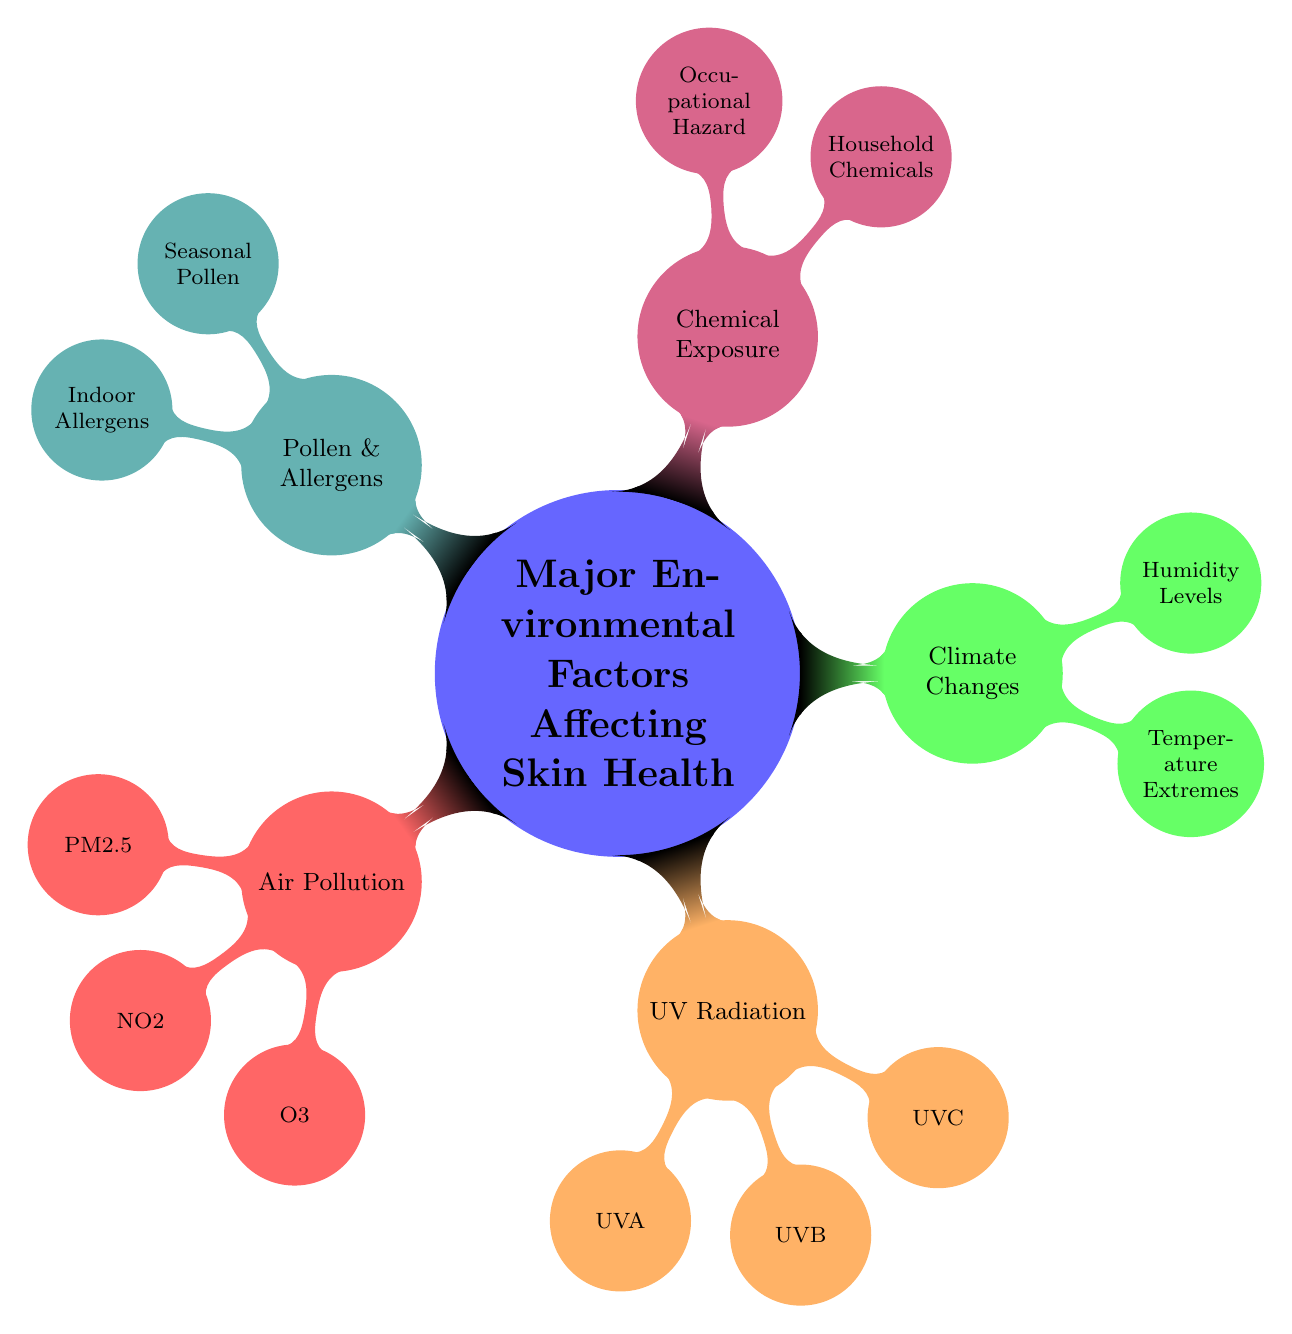What are the three main categories of environmental factors affecting skin health? The diagram shows five main categories, but the question specifically asks for three main ones. By identifying the major nodes directly connected to the central concept, we see those are Air Pollution, UV Radiation, and Climate Changes.
Answer: Air Pollution, UV Radiation, Climate Changes How many types of UV radiation are listed in the diagram? The node for UV Radiation branches out to three specific types: UVA, UVB, and UVC. Therefore, counting these gives us a total of three types of UV radiation listed.
Answer: 3 What is one effect of particulate matter (PM2.5) mentioned in the diagram? The diagram provides information that lists PM2.5 as related to "Fine particles from vehicle emissions" and "Industrial emissions". Both aspects relate to its negative impact on skin health. Thus, we can choose either, but I'll select one specific effect.
Answer: Fine particles from vehicle emissions What are two household chemicals that could potentially affect skin health? Under the Chemical Exposure category, specifically under Household Chemicals, the diagram lists "Cleaning agents" and "Pesticides". We can choose either or both as potential answers.
Answer: Cleaning agents, Pesticides Which environmental factor has nodes describing temperature extremes? To answer this, I follow the branches stemming from the central node. The segment labeled "Climate Changes" has a child node called "Temperature Extremes". Therefore, this is the environmental factor associated with temperature extremes.
Answer: Climate Changes Are there more types of indoor allergens or outdoor allergens listed? The diagram shows indoor allergens under the Pollen & Allergens section, with "Dust mites" and "Pet dander" as specific examples. In contrast, outdoor allergens are represented by "Tree pollen" and "Grass pollen". Counting both categories, we find that both have two entries. Therefore, neither category has more types than the other.
Answer: Neither What type of UV radiation is primarily responsible for sunburn? The node UVB is indicated to be associated with "Sunburn" in its description. This specific connection identifies UVB as the type responsible for this effect on the skin.
Answer: UVB Which environmental factor has the effect of causing dehydration? When reviewing the Climate Changes category, the child node "Temperature Extremes" lists "Heatwaves causing dehydration" as an effect. Therefore, the direct association allows for this conclusion.
Answer: Climate Changes How many distinct factors are associated with air pollution? Under the Air Pollution category, the diagram lists three specific chemical elements: PM2.5, NO2, and O3. Counting these up leads to a total of three distinct factors related to air pollution as shown in the diagram.
Answer: 3 